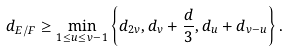<formula> <loc_0><loc_0><loc_500><loc_500>d _ { E / F } \geq \min _ { 1 \leq u \leq v - 1 } \left \{ d _ { 2 v } , d _ { v } + \frac { d } { 3 } , d _ { u } + d _ { v - u } \right \} .</formula> 